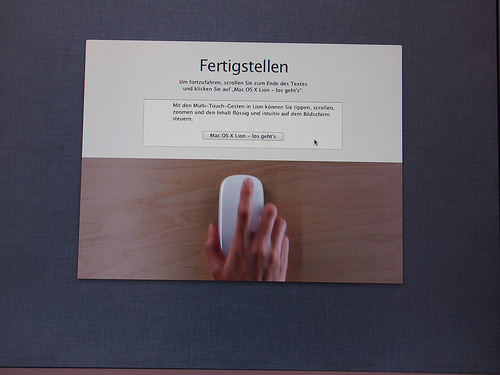<image>
Can you confirm if the mouse is under the desk? No. The mouse is not positioned under the desk. The vertical relationship between these objects is different. 